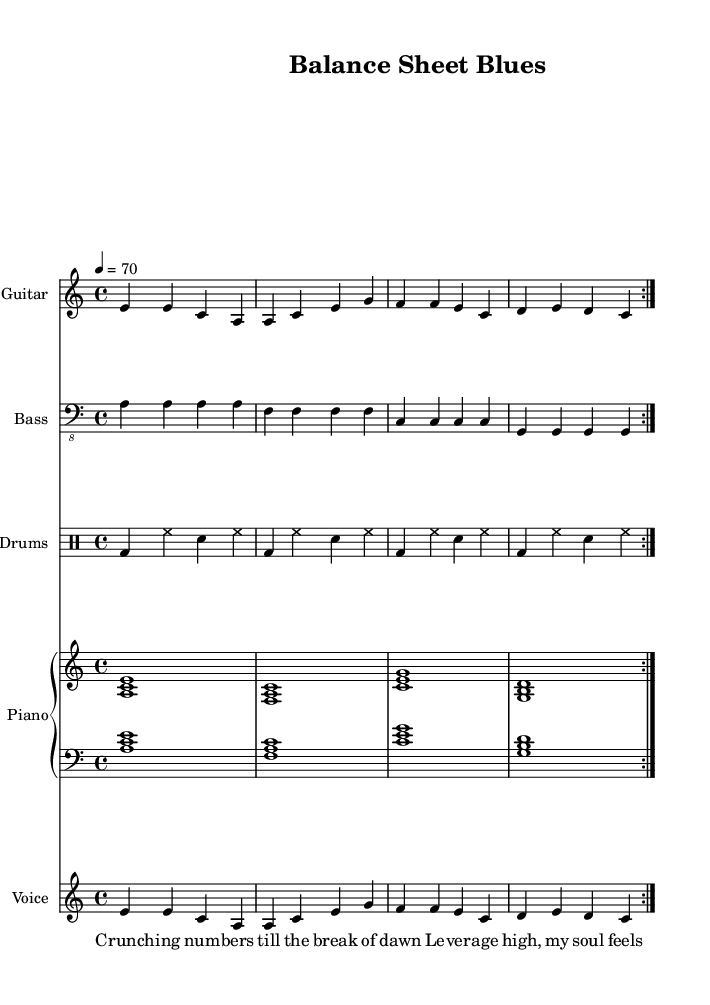What is the key signature of this music? The key signature is A minor, which is indicated prominently in the first few measures of the sheet music. This signature has no sharps and is often associated with a somber or reflective mood, aligning with the themes of work-life balance and the cost of success in the song's lyrics.
Answer: A minor What is the time signature of this music? The time signature is 4/4, which means there are four beats in each measure, typically emphasized in popular music, including rock ballads. This signature promotes a steady rhythmic flow suitable for the lyrical content that discusses balancing various aspects of life.
Answer: 4/4 What is the tempo marking for this piece? The tempo marking indicates a speed of 70 beats per minute, which is moderately slow. This tempo allows for a more reflective delivery of the lyrics, emphasizing the themes of struggle and contemplation found in the song.
Answer: 70 How many measures are repeated in the electric guitar part? The electric guitar part repeats for two measures, as denoted by the repeat volta indicators. Repetition is a common feature in rock music, reinforcing key musical ideas and enhancing the emotional impact of the lyrics.
Answer: 2 What instruments are used in this arrangement? The arrangement includes electric guitar, bass, drums, and piano. Each instrument contributes to the overall rock ballad feel, allowing for a rich interplay of melody and rhythm that complements the lyrical themes of the song.
Answer: Electric guitar, bass, drums, piano What do the lyrics suggest about the cost of success? The lyrics reflect a struggle with high leverage and the emotional toll it takes on the individual. Phrases like "Leverage high, my soul feels worn" directly point to the sacrifices made in pursuit of success, highlighting the consequences of work-life imbalance.
Answer: Emotional toll What is the structure of the lyrical content in the song? The lyrics consist of a verse followed by a chorus. This structure is typical of a rock ballad, allowing for storytelling in the verse and a catchy, relatable message in the chorus, effectively emphasizing the theme of achieving balance in life.
Answer: Verse and chorus 